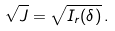Convert formula to latex. <formula><loc_0><loc_0><loc_500><loc_500>\sqrt { J } = \sqrt { I _ { r } ( \delta ) } \, .</formula> 